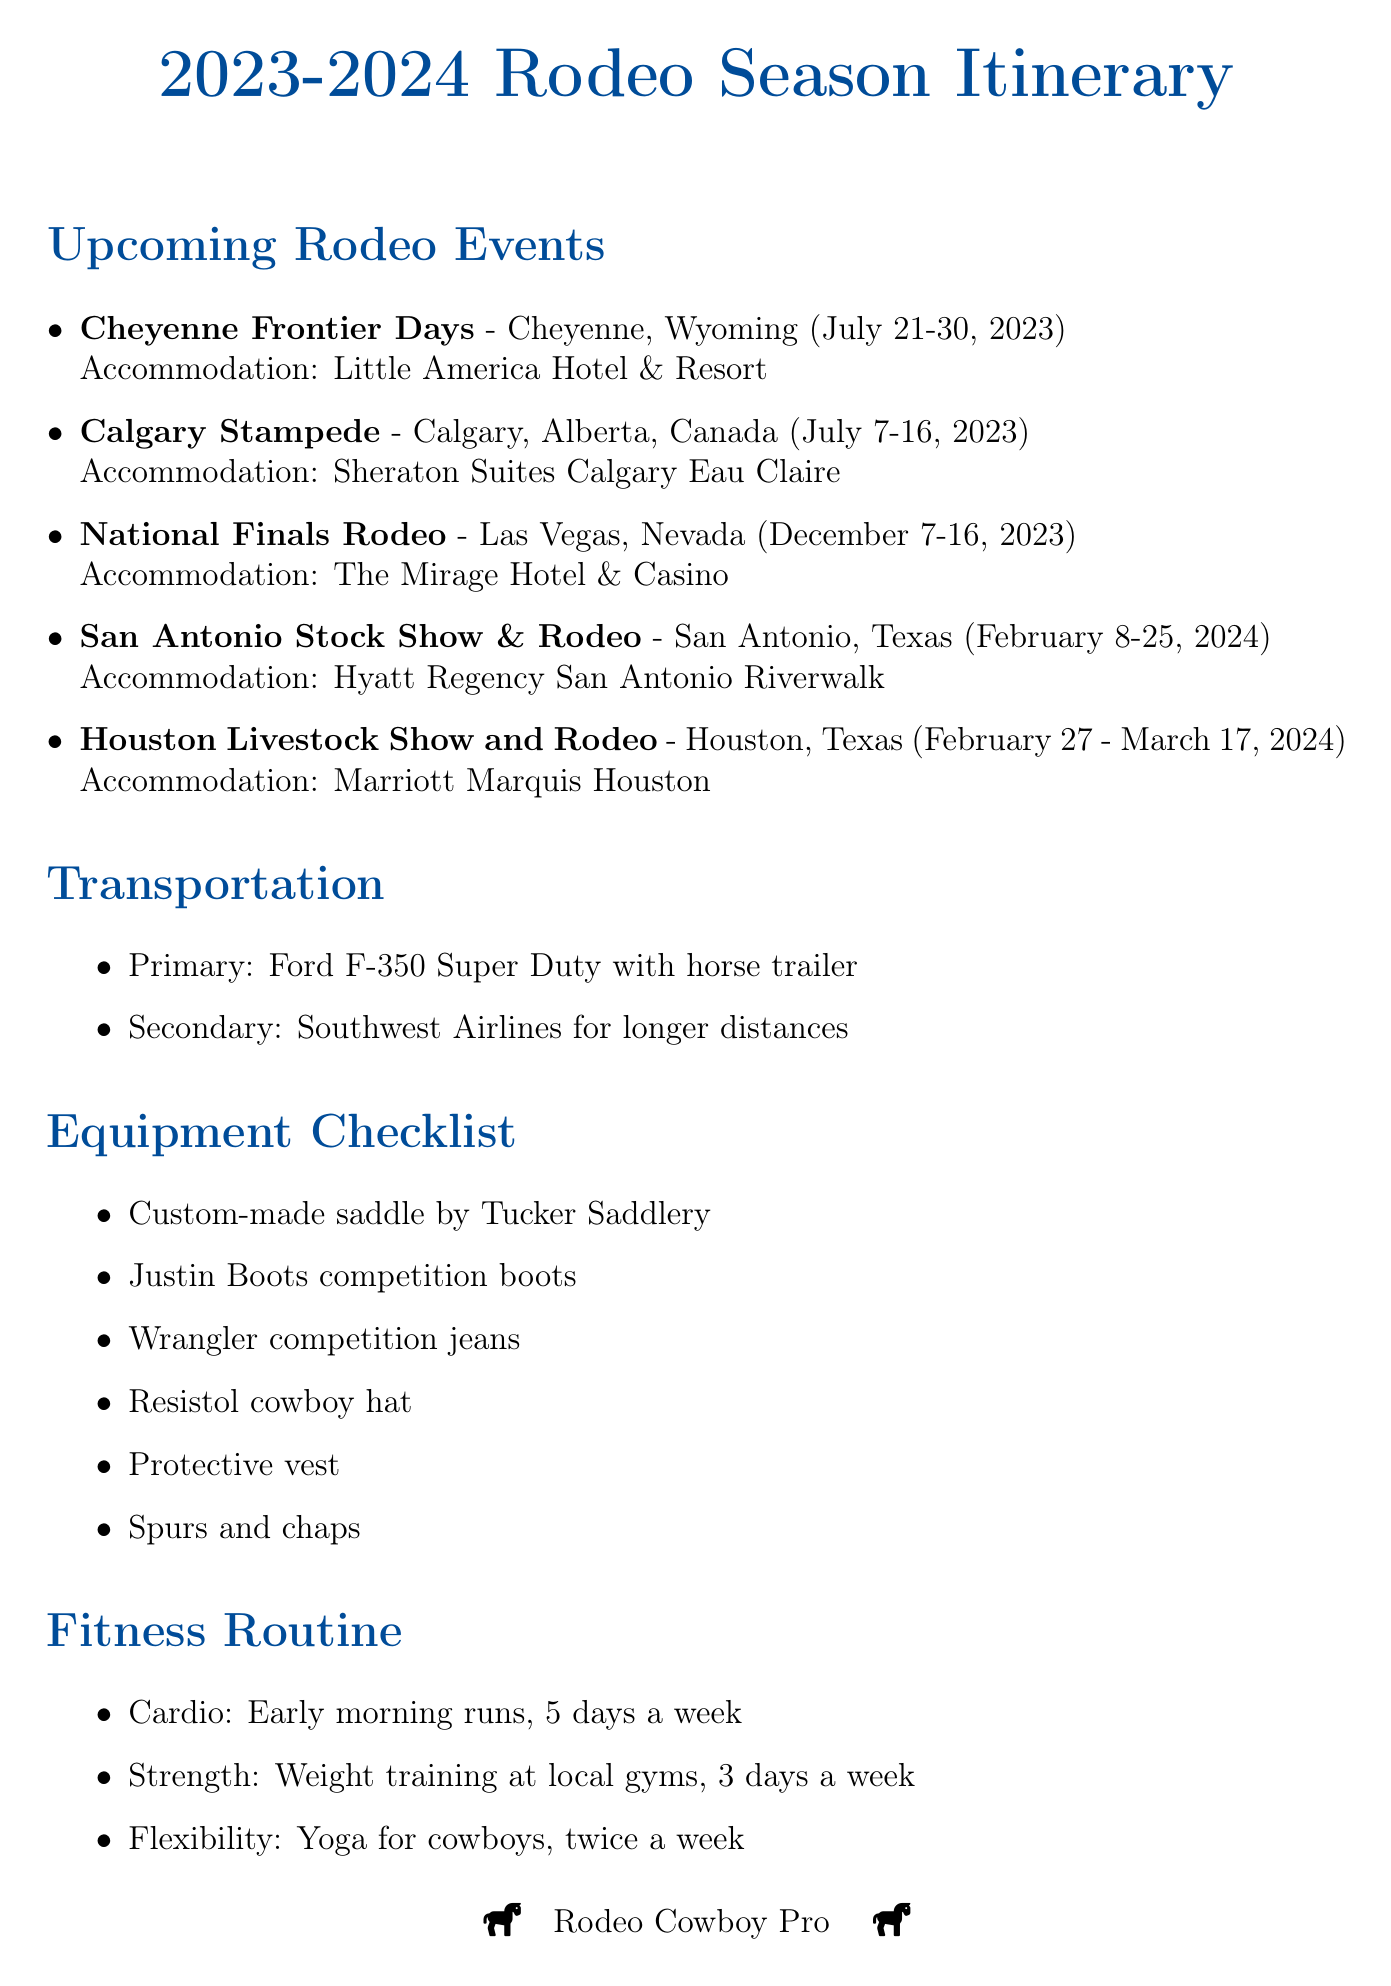What is the first event in the rodeo season? The first event listed in the document is "Calgary Stampede," which occurs before the others.
Answer: Calgary Stampede What are the dates for the National Finals Rodeo? The document states that the National Finals Rodeo takes place from December 7 to December 16, 2023.
Answer: December 7-16, 2023 Where will the San Antonio Stock Show & Rodeo be held? The location for the San Antonio Stock Show & Rodeo, according to the document, is San Antonio, Texas.
Answer: San Antonio, Texas What is the primary transportation vehicle mentioned? The document specifies that the primary transportation is a Ford F-350 Super Duty with a horse trailer.
Answer: Ford F-350 Super Duty with horse trailer How many days a week does the fitness routine include cardio? The document indicates that the fitness routine includes cardio five days a week.
Answer: 5 days What is the prize money goal for the season? The document mentions the prize money goal is $250,000.
Answer: $250,000 Who is the personal trainer listed in the support team? The document names Mike Johnson as the personal trainer.
Answer: Mike Johnson What type of hotel will be used for the Calgary Stampede? The accommodation listed for the Calgary Stampede is the Sheraton Suites Calgary Eau Claire.
Answer: Sheraton Suites Calgary Eau Claire How many rodeo events are listed in total? By counting the number of events in the document, we see that there are five events mentioned.
Answer: 5 events 